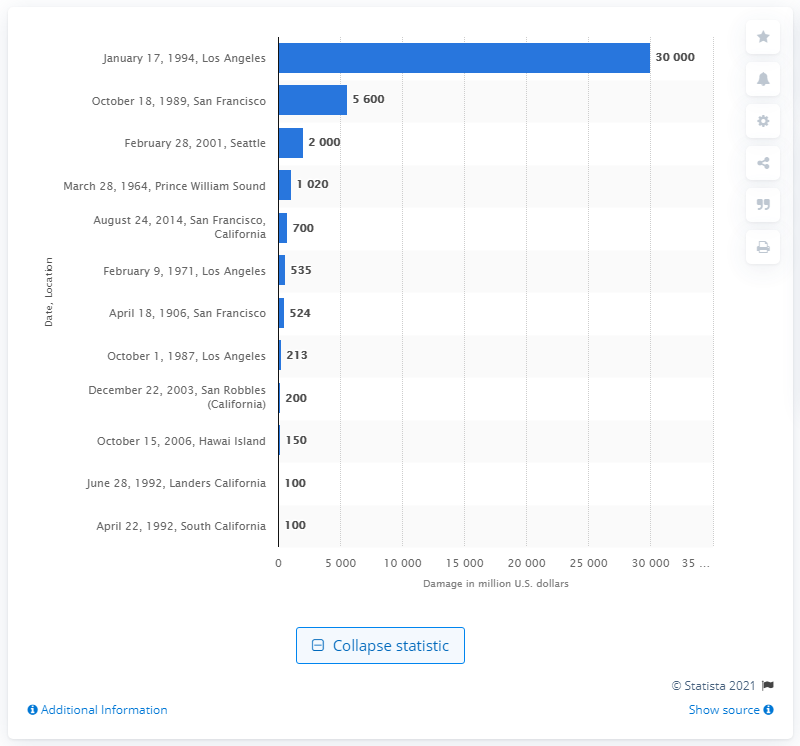Outline some significant characteristics in this image. The Los Angeles earthquake caused an estimated 30,000 in damages. 